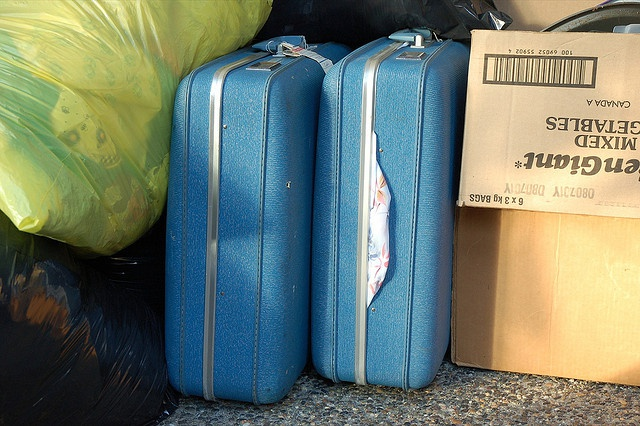Describe the objects in this image and their specific colors. I can see suitcase in khaki, blue, teal, and darkblue tones and suitcase in khaki, teal, blue, and lightblue tones in this image. 